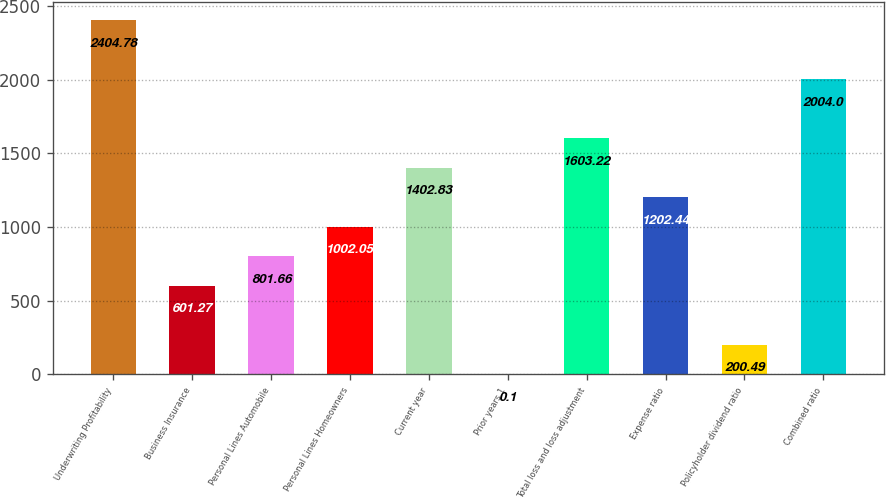<chart> <loc_0><loc_0><loc_500><loc_500><bar_chart><fcel>Underwriting Profitability<fcel>Business Insurance<fcel>Personal Lines Automobile<fcel>Personal Lines Homeowners<fcel>Current year<fcel>Prior years 1<fcel>Total loss and loss adjustment<fcel>Expense ratio<fcel>Policyholder dividend ratio<fcel>Combined ratio<nl><fcel>2404.78<fcel>601.27<fcel>801.66<fcel>1002.05<fcel>1402.83<fcel>0.1<fcel>1603.22<fcel>1202.44<fcel>200.49<fcel>2004<nl></chart> 